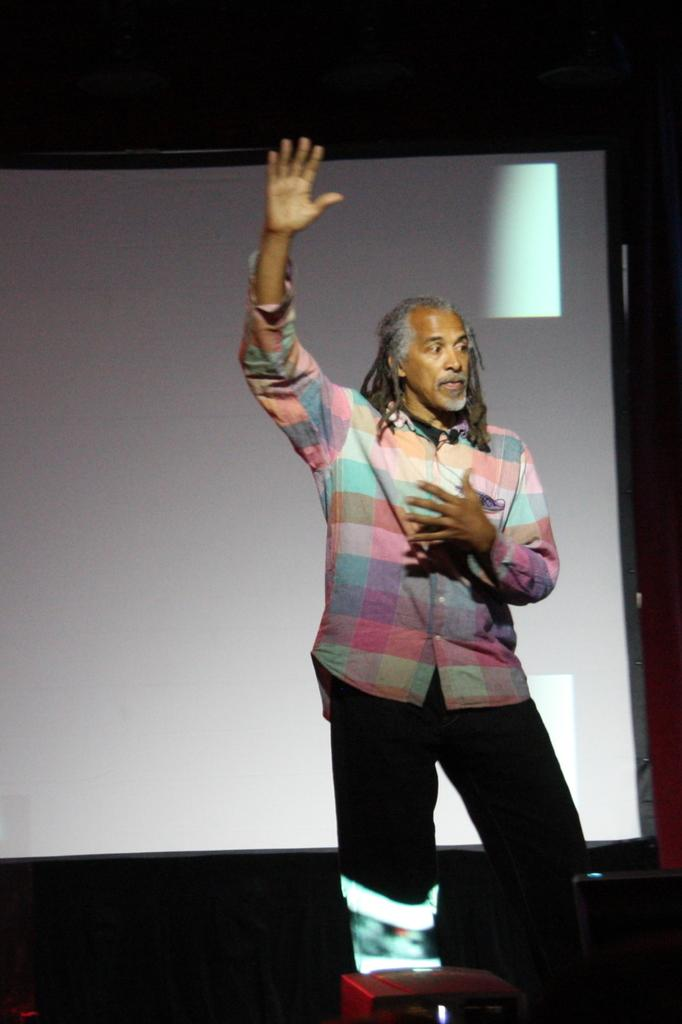What is the person in the image wearing? The person in the image is wearing a colorful dress. What can be seen on the screen in the image? The content of the screen is not visible, but a screen is present in the image. What is the color of the background in the image? The background of the image is black. How much money is being exchanged on the screen in the image? There is no indication of money or any financial transaction on the screen in the image. What type of plants are visible in the image? There are no plants visible in the image. 